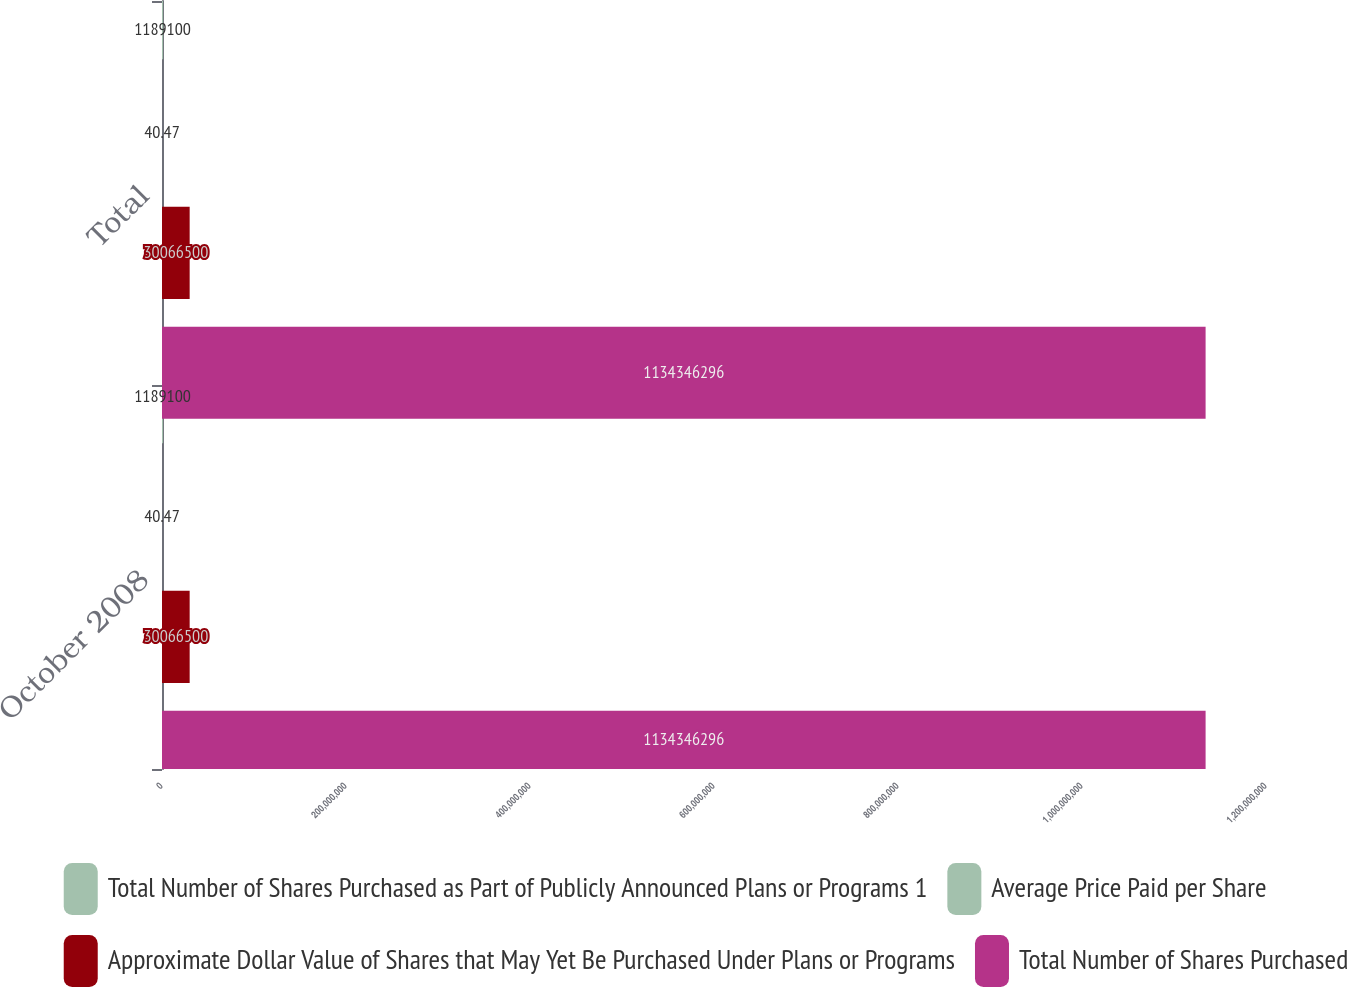Convert chart to OTSL. <chart><loc_0><loc_0><loc_500><loc_500><stacked_bar_chart><ecel><fcel>October 2008<fcel>Total<nl><fcel>Total Number of Shares Purchased as Part of Publicly Announced Plans or Programs 1<fcel>1.1891e+06<fcel>1.1891e+06<nl><fcel>Average Price Paid per Share<fcel>40.47<fcel>40.47<nl><fcel>Approximate Dollar Value of Shares that May Yet Be Purchased Under Plans or Programs<fcel>3.00665e+07<fcel>3.00665e+07<nl><fcel>Total Number of Shares Purchased<fcel>1.13435e+09<fcel>1.13435e+09<nl></chart> 